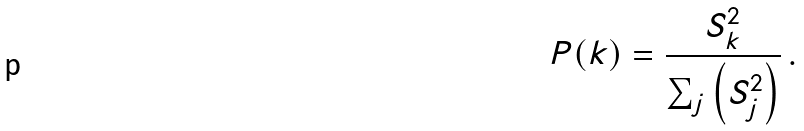Convert formula to latex. <formula><loc_0><loc_0><loc_500><loc_500>P ( k ) = \frac { S _ { k } ^ { 2 } } { \sum _ { j } \left ( S _ { j } ^ { 2 } \right ) } \, .</formula> 